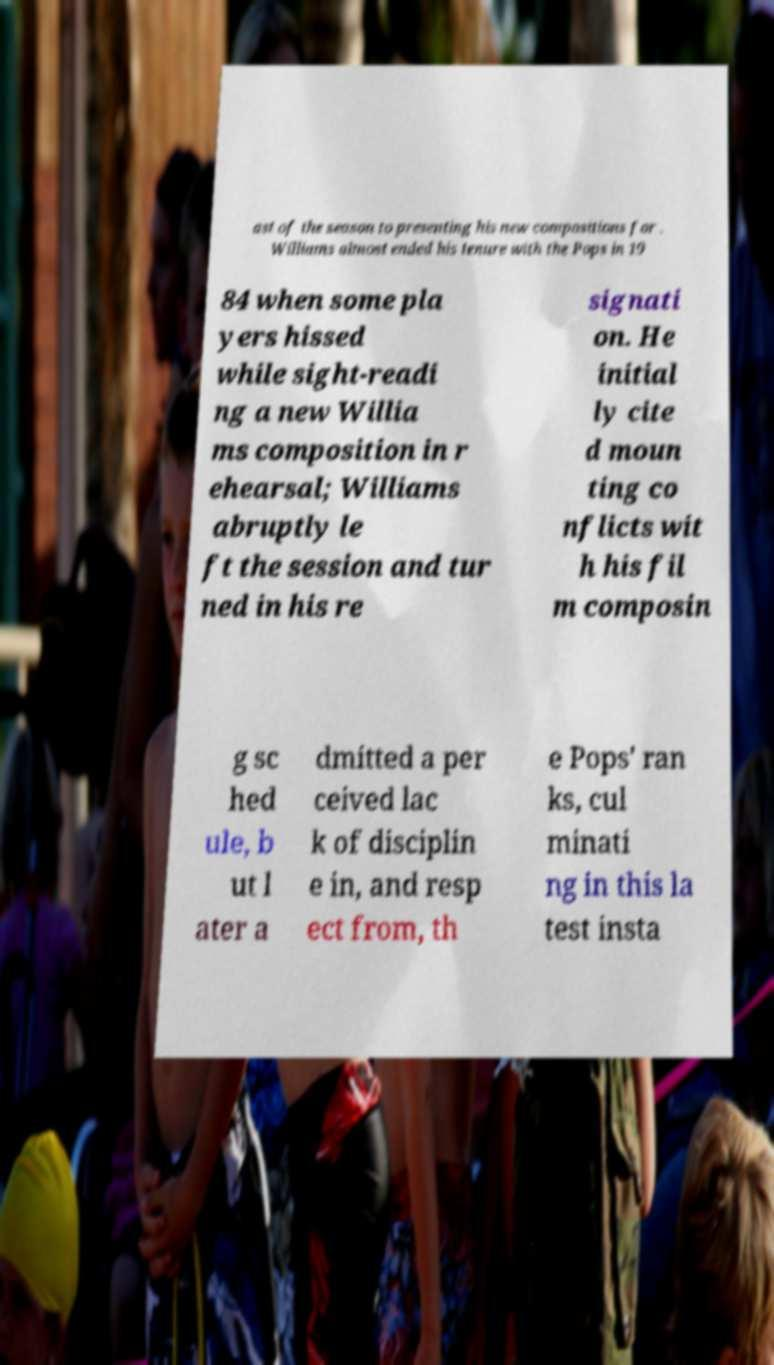What messages or text are displayed in this image? I need them in a readable, typed format. ast of the season to presenting his new compositions for . Williams almost ended his tenure with the Pops in 19 84 when some pla yers hissed while sight-readi ng a new Willia ms composition in r ehearsal; Williams abruptly le ft the session and tur ned in his re signati on. He initial ly cite d moun ting co nflicts wit h his fil m composin g sc hed ule, b ut l ater a dmitted a per ceived lac k of disciplin e in, and resp ect from, th e Pops' ran ks, cul minati ng in this la test insta 